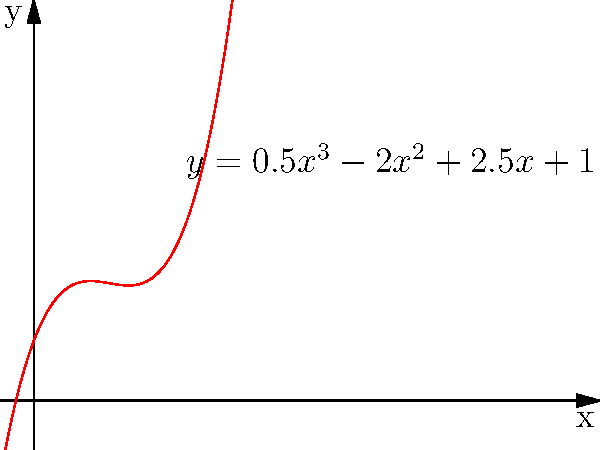In your analysis of the harmonic content of the induced voltage in a damper winding, you've approximated the voltage curve using a third-degree polynomial: $y = 0.5x^3 - 2x^2 + 2.5x + 1$. At what point does this curve have a local minimum, and what is the corresponding y-value? To find the local minimum of the polynomial $y = 0.5x^3 - 2x^2 + 2.5x + 1$, we need to follow these steps:

1) Find the derivative of the function:
   $\frac{dy}{dx} = 1.5x^2 - 4x + 2.5$

2) Set the derivative equal to zero and solve for x:
   $1.5x^2 - 4x + 2.5 = 0$

3) This is a quadratic equation. We can solve it using the quadratic formula:
   $x = \frac{-b \pm \sqrt{b^2 - 4ac}}{2a}$

   Where $a = 1.5$, $b = -4$, and $c = 2.5$

4) Plugging in these values:
   $x = \frac{4 \pm \sqrt{16 - 15}}{3} = \frac{4 \pm 1}{3}$

5) This gives us two solutions: $x = \frac{5}{3}$ and $x = 1$

6) To determine which is the minimum, we can check the second derivative:
   $\frac{d^2y}{dx^2} = 3x - 4$

   At $x = \frac{5}{3}$, this is positive, indicating a local minimum.

7) To find the y-value at this point, we plug $x = \frac{5}{3}$ into the original equation:

   $y = 0.5(\frac{5}{3})^3 - 2(\frac{5}{3})^2 + 2.5(\frac{5}{3}) + 1$
   $= 0.5(\frac{125}{27}) - 2(\frac{25}{9}) + 2.5(\frac{5}{3}) + 1$
   $\approx -0.0370$

Therefore, the local minimum occurs at $x = \frac{5}{3}$ with a y-value of approximately -0.0370.
Answer: $(\frac{5}{3}, -0.0370)$ 